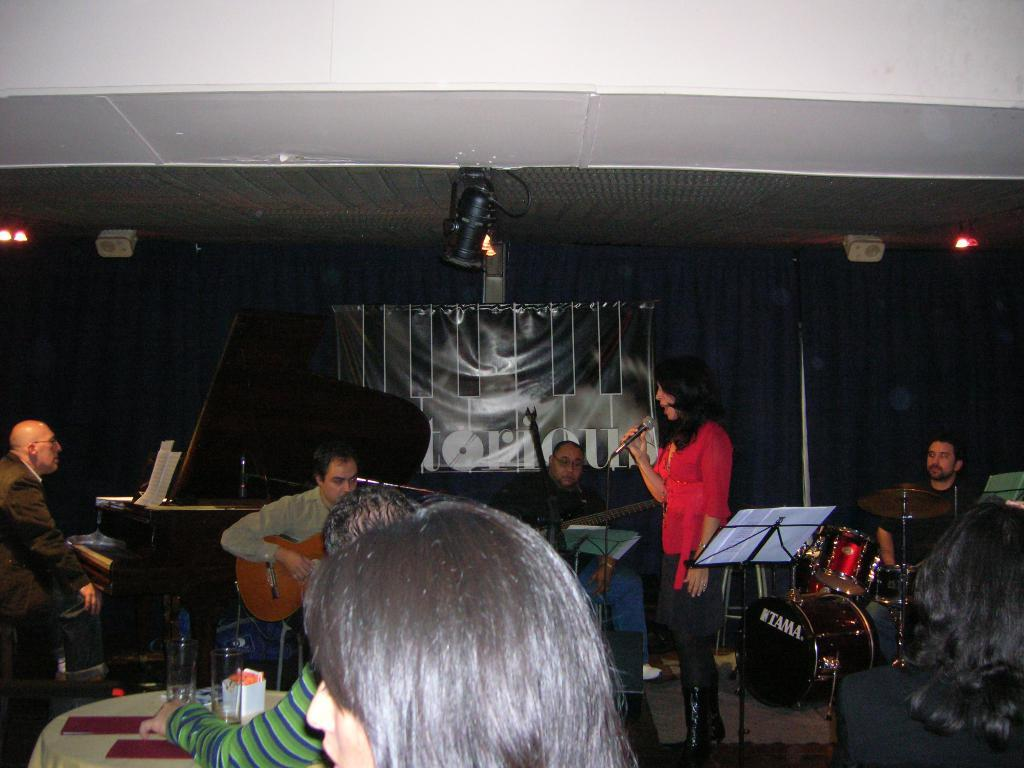What is the main activity of the people in the image? The people in the image are part of a musical band. How many people are sitting in the image? There are many people sitting in the image. Is there anyone standing in the image? Yes, one person is standing in the image. What can be seen in the image that provides light? There is a light in the image. What is on the table in the image? There is a bottle on the table. What is hanging on the wall in the image? There is a poster in the image. What type of boat is visible in the image? There is no boat present in the image. What idea does the poster on the wall represent in the image? There is no poster with an idea represented in the image; it is just a poster hanging on the wall. 